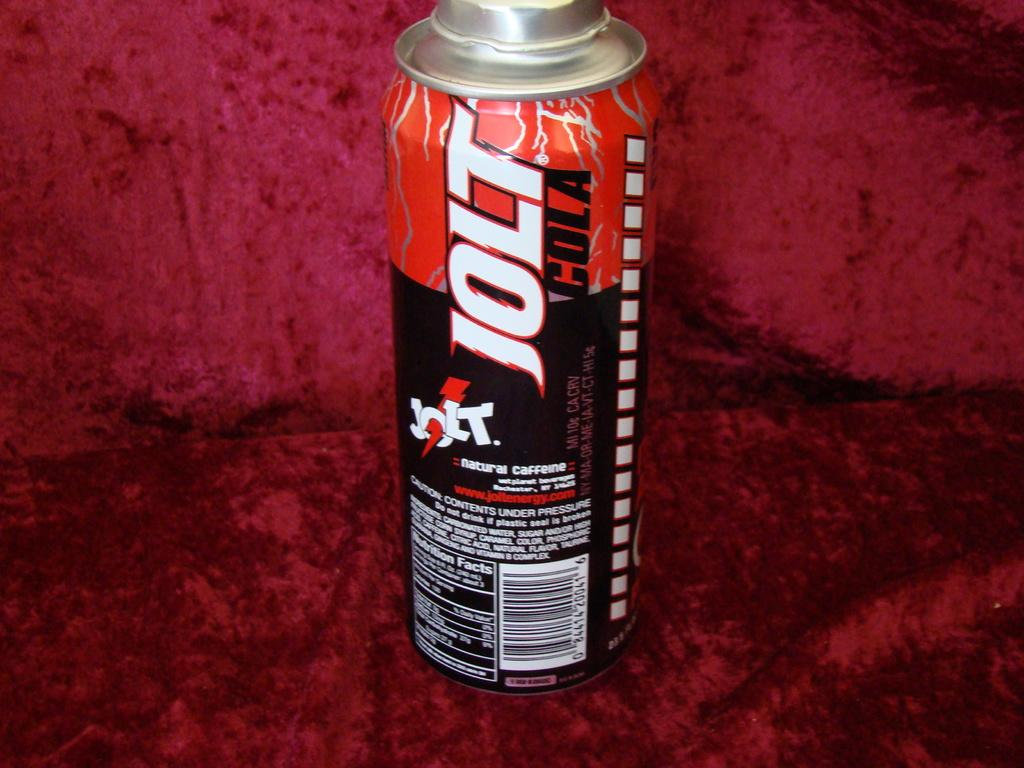<image>
Describe the image concisely. The can of Jolt cola claims it has natural caffeine in it. 